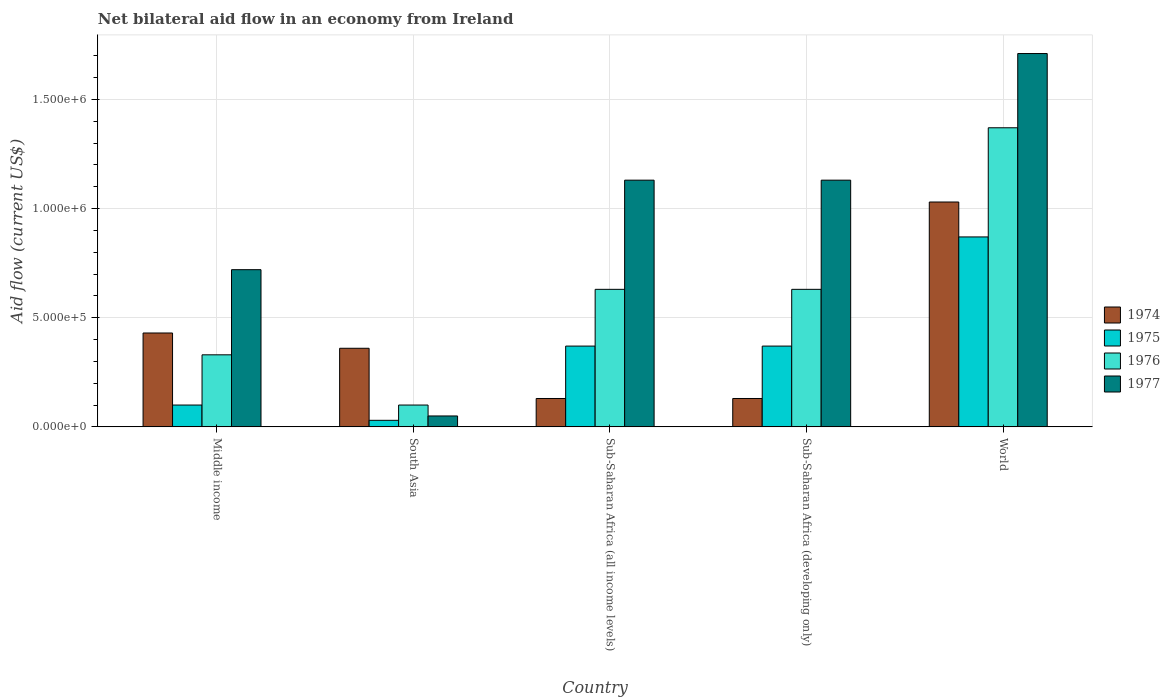How many different coloured bars are there?
Make the answer very short. 4. Are the number of bars per tick equal to the number of legend labels?
Your response must be concise. Yes. What is the label of the 3rd group of bars from the left?
Provide a succinct answer. Sub-Saharan Africa (all income levels). In how many cases, is the number of bars for a given country not equal to the number of legend labels?
Offer a terse response. 0. What is the net bilateral aid flow in 1974 in World?
Provide a succinct answer. 1.03e+06. Across all countries, what is the maximum net bilateral aid flow in 1974?
Your response must be concise. 1.03e+06. Across all countries, what is the minimum net bilateral aid flow in 1974?
Your answer should be compact. 1.30e+05. In which country was the net bilateral aid flow in 1974 maximum?
Provide a succinct answer. World. What is the total net bilateral aid flow in 1977 in the graph?
Keep it short and to the point. 4.74e+06. What is the difference between the net bilateral aid flow in 1975 in South Asia and that in Sub-Saharan Africa (developing only)?
Your answer should be compact. -3.40e+05. What is the difference between the net bilateral aid flow in 1976 in South Asia and the net bilateral aid flow in 1977 in Sub-Saharan Africa (developing only)?
Provide a succinct answer. -1.03e+06. What is the average net bilateral aid flow in 1976 per country?
Give a very brief answer. 6.12e+05. What is the difference between the net bilateral aid flow of/in 1977 and net bilateral aid flow of/in 1975 in Sub-Saharan Africa (developing only)?
Make the answer very short. 7.60e+05. What is the ratio of the net bilateral aid flow in 1974 in Middle income to that in World?
Provide a short and direct response. 0.42. Is the difference between the net bilateral aid flow in 1977 in Sub-Saharan Africa (all income levels) and Sub-Saharan Africa (developing only) greater than the difference between the net bilateral aid flow in 1975 in Sub-Saharan Africa (all income levels) and Sub-Saharan Africa (developing only)?
Provide a short and direct response. No. What is the difference between the highest and the second highest net bilateral aid flow in 1974?
Keep it short and to the point. 6.70e+05. Is the sum of the net bilateral aid flow in 1977 in South Asia and Sub-Saharan Africa (developing only) greater than the maximum net bilateral aid flow in 1976 across all countries?
Provide a succinct answer. No. What does the 1st bar from the left in Sub-Saharan Africa (developing only) represents?
Provide a succinct answer. 1974. What does the 4th bar from the right in Sub-Saharan Africa (all income levels) represents?
Make the answer very short. 1974. Is it the case that in every country, the sum of the net bilateral aid flow in 1977 and net bilateral aid flow in 1974 is greater than the net bilateral aid flow in 1975?
Keep it short and to the point. Yes. Are all the bars in the graph horizontal?
Ensure brevity in your answer.  No. How many countries are there in the graph?
Your answer should be very brief. 5. What is the difference between two consecutive major ticks on the Y-axis?
Your response must be concise. 5.00e+05. Does the graph contain any zero values?
Your answer should be very brief. No. Where does the legend appear in the graph?
Your answer should be very brief. Center right. How many legend labels are there?
Provide a succinct answer. 4. How are the legend labels stacked?
Your response must be concise. Vertical. What is the title of the graph?
Give a very brief answer. Net bilateral aid flow in an economy from Ireland. Does "2011" appear as one of the legend labels in the graph?
Provide a succinct answer. No. What is the label or title of the X-axis?
Offer a very short reply. Country. What is the Aid flow (current US$) of 1976 in Middle income?
Offer a terse response. 3.30e+05. What is the Aid flow (current US$) of 1977 in Middle income?
Offer a terse response. 7.20e+05. What is the Aid flow (current US$) of 1974 in South Asia?
Your answer should be compact. 3.60e+05. What is the Aid flow (current US$) in 1975 in South Asia?
Offer a very short reply. 3.00e+04. What is the Aid flow (current US$) in 1975 in Sub-Saharan Africa (all income levels)?
Ensure brevity in your answer.  3.70e+05. What is the Aid flow (current US$) in 1976 in Sub-Saharan Africa (all income levels)?
Offer a very short reply. 6.30e+05. What is the Aid flow (current US$) in 1977 in Sub-Saharan Africa (all income levels)?
Make the answer very short. 1.13e+06. What is the Aid flow (current US$) in 1974 in Sub-Saharan Africa (developing only)?
Your answer should be very brief. 1.30e+05. What is the Aid flow (current US$) of 1975 in Sub-Saharan Africa (developing only)?
Offer a very short reply. 3.70e+05. What is the Aid flow (current US$) of 1976 in Sub-Saharan Africa (developing only)?
Provide a short and direct response. 6.30e+05. What is the Aid flow (current US$) of 1977 in Sub-Saharan Africa (developing only)?
Give a very brief answer. 1.13e+06. What is the Aid flow (current US$) of 1974 in World?
Give a very brief answer. 1.03e+06. What is the Aid flow (current US$) in 1975 in World?
Your answer should be very brief. 8.70e+05. What is the Aid flow (current US$) in 1976 in World?
Provide a short and direct response. 1.37e+06. What is the Aid flow (current US$) in 1977 in World?
Keep it short and to the point. 1.71e+06. Across all countries, what is the maximum Aid flow (current US$) of 1974?
Offer a very short reply. 1.03e+06. Across all countries, what is the maximum Aid flow (current US$) in 1975?
Offer a terse response. 8.70e+05. Across all countries, what is the maximum Aid flow (current US$) in 1976?
Provide a short and direct response. 1.37e+06. Across all countries, what is the maximum Aid flow (current US$) in 1977?
Offer a very short reply. 1.71e+06. Across all countries, what is the minimum Aid flow (current US$) of 1977?
Offer a terse response. 5.00e+04. What is the total Aid flow (current US$) in 1974 in the graph?
Offer a terse response. 2.08e+06. What is the total Aid flow (current US$) of 1975 in the graph?
Your answer should be compact. 1.74e+06. What is the total Aid flow (current US$) of 1976 in the graph?
Your response must be concise. 3.06e+06. What is the total Aid flow (current US$) of 1977 in the graph?
Your answer should be very brief. 4.74e+06. What is the difference between the Aid flow (current US$) of 1974 in Middle income and that in South Asia?
Offer a terse response. 7.00e+04. What is the difference between the Aid flow (current US$) in 1975 in Middle income and that in South Asia?
Keep it short and to the point. 7.00e+04. What is the difference between the Aid flow (current US$) in 1976 in Middle income and that in South Asia?
Offer a very short reply. 2.30e+05. What is the difference between the Aid flow (current US$) in 1977 in Middle income and that in South Asia?
Provide a succinct answer. 6.70e+05. What is the difference between the Aid flow (current US$) of 1974 in Middle income and that in Sub-Saharan Africa (all income levels)?
Provide a succinct answer. 3.00e+05. What is the difference between the Aid flow (current US$) of 1977 in Middle income and that in Sub-Saharan Africa (all income levels)?
Offer a terse response. -4.10e+05. What is the difference between the Aid flow (current US$) of 1974 in Middle income and that in Sub-Saharan Africa (developing only)?
Ensure brevity in your answer.  3.00e+05. What is the difference between the Aid flow (current US$) in 1975 in Middle income and that in Sub-Saharan Africa (developing only)?
Make the answer very short. -2.70e+05. What is the difference between the Aid flow (current US$) in 1976 in Middle income and that in Sub-Saharan Africa (developing only)?
Offer a terse response. -3.00e+05. What is the difference between the Aid flow (current US$) in 1977 in Middle income and that in Sub-Saharan Africa (developing only)?
Offer a terse response. -4.10e+05. What is the difference between the Aid flow (current US$) of 1974 in Middle income and that in World?
Your response must be concise. -6.00e+05. What is the difference between the Aid flow (current US$) of 1975 in Middle income and that in World?
Your answer should be compact. -7.70e+05. What is the difference between the Aid flow (current US$) in 1976 in Middle income and that in World?
Ensure brevity in your answer.  -1.04e+06. What is the difference between the Aid flow (current US$) in 1977 in Middle income and that in World?
Your answer should be compact. -9.90e+05. What is the difference between the Aid flow (current US$) of 1976 in South Asia and that in Sub-Saharan Africa (all income levels)?
Give a very brief answer. -5.30e+05. What is the difference between the Aid flow (current US$) in 1977 in South Asia and that in Sub-Saharan Africa (all income levels)?
Ensure brevity in your answer.  -1.08e+06. What is the difference between the Aid flow (current US$) in 1975 in South Asia and that in Sub-Saharan Africa (developing only)?
Keep it short and to the point. -3.40e+05. What is the difference between the Aid flow (current US$) of 1976 in South Asia and that in Sub-Saharan Africa (developing only)?
Keep it short and to the point. -5.30e+05. What is the difference between the Aid flow (current US$) in 1977 in South Asia and that in Sub-Saharan Africa (developing only)?
Provide a short and direct response. -1.08e+06. What is the difference between the Aid flow (current US$) in 1974 in South Asia and that in World?
Offer a very short reply. -6.70e+05. What is the difference between the Aid flow (current US$) of 1975 in South Asia and that in World?
Make the answer very short. -8.40e+05. What is the difference between the Aid flow (current US$) of 1976 in South Asia and that in World?
Offer a terse response. -1.27e+06. What is the difference between the Aid flow (current US$) in 1977 in South Asia and that in World?
Your response must be concise. -1.66e+06. What is the difference between the Aid flow (current US$) of 1974 in Sub-Saharan Africa (all income levels) and that in Sub-Saharan Africa (developing only)?
Offer a very short reply. 0. What is the difference between the Aid flow (current US$) of 1977 in Sub-Saharan Africa (all income levels) and that in Sub-Saharan Africa (developing only)?
Your answer should be compact. 0. What is the difference between the Aid flow (current US$) in 1974 in Sub-Saharan Africa (all income levels) and that in World?
Your answer should be compact. -9.00e+05. What is the difference between the Aid flow (current US$) in 1975 in Sub-Saharan Africa (all income levels) and that in World?
Your answer should be very brief. -5.00e+05. What is the difference between the Aid flow (current US$) of 1976 in Sub-Saharan Africa (all income levels) and that in World?
Give a very brief answer. -7.40e+05. What is the difference between the Aid flow (current US$) of 1977 in Sub-Saharan Africa (all income levels) and that in World?
Keep it short and to the point. -5.80e+05. What is the difference between the Aid flow (current US$) of 1974 in Sub-Saharan Africa (developing only) and that in World?
Ensure brevity in your answer.  -9.00e+05. What is the difference between the Aid flow (current US$) of 1975 in Sub-Saharan Africa (developing only) and that in World?
Ensure brevity in your answer.  -5.00e+05. What is the difference between the Aid flow (current US$) of 1976 in Sub-Saharan Africa (developing only) and that in World?
Keep it short and to the point. -7.40e+05. What is the difference between the Aid flow (current US$) of 1977 in Sub-Saharan Africa (developing only) and that in World?
Offer a very short reply. -5.80e+05. What is the difference between the Aid flow (current US$) in 1974 in Middle income and the Aid flow (current US$) in 1975 in South Asia?
Keep it short and to the point. 4.00e+05. What is the difference between the Aid flow (current US$) in 1974 in Middle income and the Aid flow (current US$) in 1977 in South Asia?
Provide a short and direct response. 3.80e+05. What is the difference between the Aid flow (current US$) of 1974 in Middle income and the Aid flow (current US$) of 1976 in Sub-Saharan Africa (all income levels)?
Provide a succinct answer. -2.00e+05. What is the difference between the Aid flow (current US$) in 1974 in Middle income and the Aid flow (current US$) in 1977 in Sub-Saharan Africa (all income levels)?
Offer a very short reply. -7.00e+05. What is the difference between the Aid flow (current US$) of 1975 in Middle income and the Aid flow (current US$) of 1976 in Sub-Saharan Africa (all income levels)?
Ensure brevity in your answer.  -5.30e+05. What is the difference between the Aid flow (current US$) in 1975 in Middle income and the Aid flow (current US$) in 1977 in Sub-Saharan Africa (all income levels)?
Your answer should be compact. -1.03e+06. What is the difference between the Aid flow (current US$) of 1976 in Middle income and the Aid flow (current US$) of 1977 in Sub-Saharan Africa (all income levels)?
Your response must be concise. -8.00e+05. What is the difference between the Aid flow (current US$) in 1974 in Middle income and the Aid flow (current US$) in 1976 in Sub-Saharan Africa (developing only)?
Ensure brevity in your answer.  -2.00e+05. What is the difference between the Aid flow (current US$) in 1974 in Middle income and the Aid flow (current US$) in 1977 in Sub-Saharan Africa (developing only)?
Keep it short and to the point. -7.00e+05. What is the difference between the Aid flow (current US$) of 1975 in Middle income and the Aid flow (current US$) of 1976 in Sub-Saharan Africa (developing only)?
Keep it short and to the point. -5.30e+05. What is the difference between the Aid flow (current US$) in 1975 in Middle income and the Aid flow (current US$) in 1977 in Sub-Saharan Africa (developing only)?
Keep it short and to the point. -1.03e+06. What is the difference between the Aid flow (current US$) of 1976 in Middle income and the Aid flow (current US$) of 1977 in Sub-Saharan Africa (developing only)?
Your answer should be compact. -8.00e+05. What is the difference between the Aid flow (current US$) of 1974 in Middle income and the Aid flow (current US$) of 1975 in World?
Your answer should be compact. -4.40e+05. What is the difference between the Aid flow (current US$) in 1974 in Middle income and the Aid flow (current US$) in 1976 in World?
Your response must be concise. -9.40e+05. What is the difference between the Aid flow (current US$) of 1974 in Middle income and the Aid flow (current US$) of 1977 in World?
Offer a terse response. -1.28e+06. What is the difference between the Aid flow (current US$) in 1975 in Middle income and the Aid flow (current US$) in 1976 in World?
Make the answer very short. -1.27e+06. What is the difference between the Aid flow (current US$) of 1975 in Middle income and the Aid flow (current US$) of 1977 in World?
Provide a succinct answer. -1.61e+06. What is the difference between the Aid flow (current US$) in 1976 in Middle income and the Aid flow (current US$) in 1977 in World?
Ensure brevity in your answer.  -1.38e+06. What is the difference between the Aid flow (current US$) of 1974 in South Asia and the Aid flow (current US$) of 1976 in Sub-Saharan Africa (all income levels)?
Offer a very short reply. -2.70e+05. What is the difference between the Aid flow (current US$) in 1974 in South Asia and the Aid flow (current US$) in 1977 in Sub-Saharan Africa (all income levels)?
Your answer should be very brief. -7.70e+05. What is the difference between the Aid flow (current US$) in 1975 in South Asia and the Aid flow (current US$) in 1976 in Sub-Saharan Africa (all income levels)?
Offer a very short reply. -6.00e+05. What is the difference between the Aid flow (current US$) of 1975 in South Asia and the Aid flow (current US$) of 1977 in Sub-Saharan Africa (all income levels)?
Your response must be concise. -1.10e+06. What is the difference between the Aid flow (current US$) of 1976 in South Asia and the Aid flow (current US$) of 1977 in Sub-Saharan Africa (all income levels)?
Offer a very short reply. -1.03e+06. What is the difference between the Aid flow (current US$) of 1974 in South Asia and the Aid flow (current US$) of 1976 in Sub-Saharan Africa (developing only)?
Offer a very short reply. -2.70e+05. What is the difference between the Aid flow (current US$) in 1974 in South Asia and the Aid flow (current US$) in 1977 in Sub-Saharan Africa (developing only)?
Provide a short and direct response. -7.70e+05. What is the difference between the Aid flow (current US$) of 1975 in South Asia and the Aid flow (current US$) of 1976 in Sub-Saharan Africa (developing only)?
Your response must be concise. -6.00e+05. What is the difference between the Aid flow (current US$) of 1975 in South Asia and the Aid flow (current US$) of 1977 in Sub-Saharan Africa (developing only)?
Offer a very short reply. -1.10e+06. What is the difference between the Aid flow (current US$) in 1976 in South Asia and the Aid flow (current US$) in 1977 in Sub-Saharan Africa (developing only)?
Keep it short and to the point. -1.03e+06. What is the difference between the Aid flow (current US$) of 1974 in South Asia and the Aid flow (current US$) of 1975 in World?
Make the answer very short. -5.10e+05. What is the difference between the Aid flow (current US$) in 1974 in South Asia and the Aid flow (current US$) in 1976 in World?
Offer a very short reply. -1.01e+06. What is the difference between the Aid flow (current US$) in 1974 in South Asia and the Aid flow (current US$) in 1977 in World?
Provide a succinct answer. -1.35e+06. What is the difference between the Aid flow (current US$) in 1975 in South Asia and the Aid flow (current US$) in 1976 in World?
Your answer should be very brief. -1.34e+06. What is the difference between the Aid flow (current US$) of 1975 in South Asia and the Aid flow (current US$) of 1977 in World?
Make the answer very short. -1.68e+06. What is the difference between the Aid flow (current US$) of 1976 in South Asia and the Aid flow (current US$) of 1977 in World?
Provide a succinct answer. -1.61e+06. What is the difference between the Aid flow (current US$) of 1974 in Sub-Saharan Africa (all income levels) and the Aid flow (current US$) of 1976 in Sub-Saharan Africa (developing only)?
Ensure brevity in your answer.  -5.00e+05. What is the difference between the Aid flow (current US$) of 1974 in Sub-Saharan Africa (all income levels) and the Aid flow (current US$) of 1977 in Sub-Saharan Africa (developing only)?
Offer a very short reply. -1.00e+06. What is the difference between the Aid flow (current US$) of 1975 in Sub-Saharan Africa (all income levels) and the Aid flow (current US$) of 1977 in Sub-Saharan Africa (developing only)?
Offer a very short reply. -7.60e+05. What is the difference between the Aid flow (current US$) of 1976 in Sub-Saharan Africa (all income levels) and the Aid flow (current US$) of 1977 in Sub-Saharan Africa (developing only)?
Provide a short and direct response. -5.00e+05. What is the difference between the Aid flow (current US$) in 1974 in Sub-Saharan Africa (all income levels) and the Aid flow (current US$) in 1975 in World?
Your answer should be very brief. -7.40e+05. What is the difference between the Aid flow (current US$) in 1974 in Sub-Saharan Africa (all income levels) and the Aid flow (current US$) in 1976 in World?
Your answer should be very brief. -1.24e+06. What is the difference between the Aid flow (current US$) in 1974 in Sub-Saharan Africa (all income levels) and the Aid flow (current US$) in 1977 in World?
Your answer should be compact. -1.58e+06. What is the difference between the Aid flow (current US$) of 1975 in Sub-Saharan Africa (all income levels) and the Aid flow (current US$) of 1976 in World?
Your answer should be very brief. -1.00e+06. What is the difference between the Aid flow (current US$) of 1975 in Sub-Saharan Africa (all income levels) and the Aid flow (current US$) of 1977 in World?
Provide a short and direct response. -1.34e+06. What is the difference between the Aid flow (current US$) of 1976 in Sub-Saharan Africa (all income levels) and the Aid flow (current US$) of 1977 in World?
Your answer should be compact. -1.08e+06. What is the difference between the Aid flow (current US$) of 1974 in Sub-Saharan Africa (developing only) and the Aid flow (current US$) of 1975 in World?
Ensure brevity in your answer.  -7.40e+05. What is the difference between the Aid flow (current US$) in 1974 in Sub-Saharan Africa (developing only) and the Aid flow (current US$) in 1976 in World?
Give a very brief answer. -1.24e+06. What is the difference between the Aid flow (current US$) in 1974 in Sub-Saharan Africa (developing only) and the Aid flow (current US$) in 1977 in World?
Keep it short and to the point. -1.58e+06. What is the difference between the Aid flow (current US$) in 1975 in Sub-Saharan Africa (developing only) and the Aid flow (current US$) in 1976 in World?
Provide a succinct answer. -1.00e+06. What is the difference between the Aid flow (current US$) of 1975 in Sub-Saharan Africa (developing only) and the Aid flow (current US$) of 1977 in World?
Offer a terse response. -1.34e+06. What is the difference between the Aid flow (current US$) in 1976 in Sub-Saharan Africa (developing only) and the Aid flow (current US$) in 1977 in World?
Ensure brevity in your answer.  -1.08e+06. What is the average Aid flow (current US$) in 1974 per country?
Your answer should be compact. 4.16e+05. What is the average Aid flow (current US$) in 1975 per country?
Offer a very short reply. 3.48e+05. What is the average Aid flow (current US$) of 1976 per country?
Provide a succinct answer. 6.12e+05. What is the average Aid flow (current US$) of 1977 per country?
Your answer should be very brief. 9.48e+05. What is the difference between the Aid flow (current US$) in 1974 and Aid flow (current US$) in 1976 in Middle income?
Offer a terse response. 1.00e+05. What is the difference between the Aid flow (current US$) of 1975 and Aid flow (current US$) of 1977 in Middle income?
Your response must be concise. -6.20e+05. What is the difference between the Aid flow (current US$) in 1976 and Aid flow (current US$) in 1977 in Middle income?
Your response must be concise. -3.90e+05. What is the difference between the Aid flow (current US$) in 1974 and Aid flow (current US$) in 1976 in South Asia?
Ensure brevity in your answer.  2.60e+05. What is the difference between the Aid flow (current US$) in 1974 and Aid flow (current US$) in 1977 in South Asia?
Keep it short and to the point. 3.10e+05. What is the difference between the Aid flow (current US$) in 1976 and Aid flow (current US$) in 1977 in South Asia?
Your answer should be compact. 5.00e+04. What is the difference between the Aid flow (current US$) of 1974 and Aid flow (current US$) of 1975 in Sub-Saharan Africa (all income levels)?
Offer a terse response. -2.40e+05. What is the difference between the Aid flow (current US$) in 1974 and Aid flow (current US$) in 1976 in Sub-Saharan Africa (all income levels)?
Your response must be concise. -5.00e+05. What is the difference between the Aid flow (current US$) of 1975 and Aid flow (current US$) of 1977 in Sub-Saharan Africa (all income levels)?
Provide a short and direct response. -7.60e+05. What is the difference between the Aid flow (current US$) in 1976 and Aid flow (current US$) in 1977 in Sub-Saharan Africa (all income levels)?
Your answer should be compact. -5.00e+05. What is the difference between the Aid flow (current US$) in 1974 and Aid flow (current US$) in 1976 in Sub-Saharan Africa (developing only)?
Offer a very short reply. -5.00e+05. What is the difference between the Aid flow (current US$) of 1974 and Aid flow (current US$) of 1977 in Sub-Saharan Africa (developing only)?
Your response must be concise. -1.00e+06. What is the difference between the Aid flow (current US$) of 1975 and Aid flow (current US$) of 1977 in Sub-Saharan Africa (developing only)?
Offer a very short reply. -7.60e+05. What is the difference between the Aid flow (current US$) of 1976 and Aid flow (current US$) of 1977 in Sub-Saharan Africa (developing only)?
Give a very brief answer. -5.00e+05. What is the difference between the Aid flow (current US$) in 1974 and Aid flow (current US$) in 1975 in World?
Provide a succinct answer. 1.60e+05. What is the difference between the Aid flow (current US$) of 1974 and Aid flow (current US$) of 1976 in World?
Give a very brief answer. -3.40e+05. What is the difference between the Aid flow (current US$) of 1974 and Aid flow (current US$) of 1977 in World?
Provide a short and direct response. -6.80e+05. What is the difference between the Aid flow (current US$) of 1975 and Aid flow (current US$) of 1976 in World?
Ensure brevity in your answer.  -5.00e+05. What is the difference between the Aid flow (current US$) in 1975 and Aid flow (current US$) in 1977 in World?
Your answer should be compact. -8.40e+05. What is the ratio of the Aid flow (current US$) in 1974 in Middle income to that in South Asia?
Ensure brevity in your answer.  1.19. What is the ratio of the Aid flow (current US$) of 1975 in Middle income to that in South Asia?
Provide a succinct answer. 3.33. What is the ratio of the Aid flow (current US$) of 1974 in Middle income to that in Sub-Saharan Africa (all income levels)?
Your answer should be very brief. 3.31. What is the ratio of the Aid flow (current US$) in 1975 in Middle income to that in Sub-Saharan Africa (all income levels)?
Keep it short and to the point. 0.27. What is the ratio of the Aid flow (current US$) of 1976 in Middle income to that in Sub-Saharan Africa (all income levels)?
Give a very brief answer. 0.52. What is the ratio of the Aid flow (current US$) of 1977 in Middle income to that in Sub-Saharan Africa (all income levels)?
Offer a terse response. 0.64. What is the ratio of the Aid flow (current US$) of 1974 in Middle income to that in Sub-Saharan Africa (developing only)?
Provide a short and direct response. 3.31. What is the ratio of the Aid flow (current US$) of 1975 in Middle income to that in Sub-Saharan Africa (developing only)?
Provide a short and direct response. 0.27. What is the ratio of the Aid flow (current US$) in 1976 in Middle income to that in Sub-Saharan Africa (developing only)?
Your answer should be compact. 0.52. What is the ratio of the Aid flow (current US$) in 1977 in Middle income to that in Sub-Saharan Africa (developing only)?
Your answer should be compact. 0.64. What is the ratio of the Aid flow (current US$) of 1974 in Middle income to that in World?
Provide a succinct answer. 0.42. What is the ratio of the Aid flow (current US$) in 1975 in Middle income to that in World?
Provide a succinct answer. 0.11. What is the ratio of the Aid flow (current US$) of 1976 in Middle income to that in World?
Offer a very short reply. 0.24. What is the ratio of the Aid flow (current US$) in 1977 in Middle income to that in World?
Offer a very short reply. 0.42. What is the ratio of the Aid flow (current US$) of 1974 in South Asia to that in Sub-Saharan Africa (all income levels)?
Offer a terse response. 2.77. What is the ratio of the Aid flow (current US$) of 1975 in South Asia to that in Sub-Saharan Africa (all income levels)?
Keep it short and to the point. 0.08. What is the ratio of the Aid flow (current US$) of 1976 in South Asia to that in Sub-Saharan Africa (all income levels)?
Offer a terse response. 0.16. What is the ratio of the Aid flow (current US$) of 1977 in South Asia to that in Sub-Saharan Africa (all income levels)?
Provide a succinct answer. 0.04. What is the ratio of the Aid flow (current US$) in 1974 in South Asia to that in Sub-Saharan Africa (developing only)?
Provide a succinct answer. 2.77. What is the ratio of the Aid flow (current US$) of 1975 in South Asia to that in Sub-Saharan Africa (developing only)?
Your answer should be very brief. 0.08. What is the ratio of the Aid flow (current US$) of 1976 in South Asia to that in Sub-Saharan Africa (developing only)?
Provide a succinct answer. 0.16. What is the ratio of the Aid flow (current US$) of 1977 in South Asia to that in Sub-Saharan Africa (developing only)?
Your answer should be compact. 0.04. What is the ratio of the Aid flow (current US$) of 1974 in South Asia to that in World?
Give a very brief answer. 0.35. What is the ratio of the Aid flow (current US$) of 1975 in South Asia to that in World?
Your answer should be very brief. 0.03. What is the ratio of the Aid flow (current US$) in 1976 in South Asia to that in World?
Your answer should be compact. 0.07. What is the ratio of the Aid flow (current US$) of 1977 in South Asia to that in World?
Give a very brief answer. 0.03. What is the ratio of the Aid flow (current US$) of 1976 in Sub-Saharan Africa (all income levels) to that in Sub-Saharan Africa (developing only)?
Provide a short and direct response. 1. What is the ratio of the Aid flow (current US$) of 1977 in Sub-Saharan Africa (all income levels) to that in Sub-Saharan Africa (developing only)?
Ensure brevity in your answer.  1. What is the ratio of the Aid flow (current US$) of 1974 in Sub-Saharan Africa (all income levels) to that in World?
Keep it short and to the point. 0.13. What is the ratio of the Aid flow (current US$) of 1975 in Sub-Saharan Africa (all income levels) to that in World?
Provide a short and direct response. 0.43. What is the ratio of the Aid flow (current US$) in 1976 in Sub-Saharan Africa (all income levels) to that in World?
Your response must be concise. 0.46. What is the ratio of the Aid flow (current US$) of 1977 in Sub-Saharan Africa (all income levels) to that in World?
Your answer should be compact. 0.66. What is the ratio of the Aid flow (current US$) in 1974 in Sub-Saharan Africa (developing only) to that in World?
Offer a very short reply. 0.13. What is the ratio of the Aid flow (current US$) in 1975 in Sub-Saharan Africa (developing only) to that in World?
Offer a terse response. 0.43. What is the ratio of the Aid flow (current US$) of 1976 in Sub-Saharan Africa (developing only) to that in World?
Your answer should be compact. 0.46. What is the ratio of the Aid flow (current US$) in 1977 in Sub-Saharan Africa (developing only) to that in World?
Offer a terse response. 0.66. What is the difference between the highest and the second highest Aid flow (current US$) of 1974?
Provide a succinct answer. 6.00e+05. What is the difference between the highest and the second highest Aid flow (current US$) in 1976?
Keep it short and to the point. 7.40e+05. What is the difference between the highest and the second highest Aid flow (current US$) in 1977?
Keep it short and to the point. 5.80e+05. What is the difference between the highest and the lowest Aid flow (current US$) in 1974?
Your answer should be compact. 9.00e+05. What is the difference between the highest and the lowest Aid flow (current US$) of 1975?
Offer a very short reply. 8.40e+05. What is the difference between the highest and the lowest Aid flow (current US$) of 1976?
Provide a short and direct response. 1.27e+06. What is the difference between the highest and the lowest Aid flow (current US$) in 1977?
Your response must be concise. 1.66e+06. 